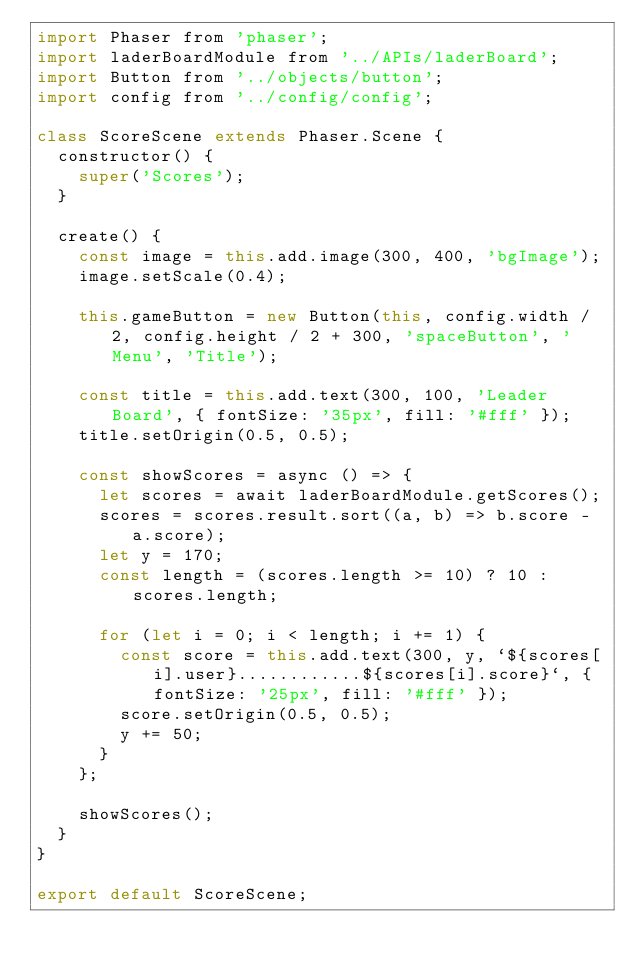<code> <loc_0><loc_0><loc_500><loc_500><_JavaScript_>import Phaser from 'phaser';
import laderBoardModule from '../APIs/laderBoard';
import Button from '../objects/button';
import config from '../config/config';

class ScoreScene extends Phaser.Scene {
  constructor() {
    super('Scores');
  }

  create() {
    const image = this.add.image(300, 400, 'bgImage');
    image.setScale(0.4);

    this.gameButton = new Button(this, config.width / 2, config.height / 2 + 300, 'spaceButton', 'Menu', 'Title');

    const title = this.add.text(300, 100, 'Leader Board', { fontSize: '35px', fill: '#fff' });
    title.setOrigin(0.5, 0.5);

    const showScores = async () => {
      let scores = await laderBoardModule.getScores();
      scores = scores.result.sort((a, b) => b.score - a.score);
      let y = 170;
      const length = (scores.length >= 10) ? 10 : scores.length;

      for (let i = 0; i < length; i += 1) {
        const score = this.add.text(300, y, `${scores[i].user}............${scores[i].score}`, { fontSize: '25px', fill: '#fff' });
        score.setOrigin(0.5, 0.5);
        y += 50;
      }
    };

    showScores();
  }
}

export default ScoreScene;</code> 